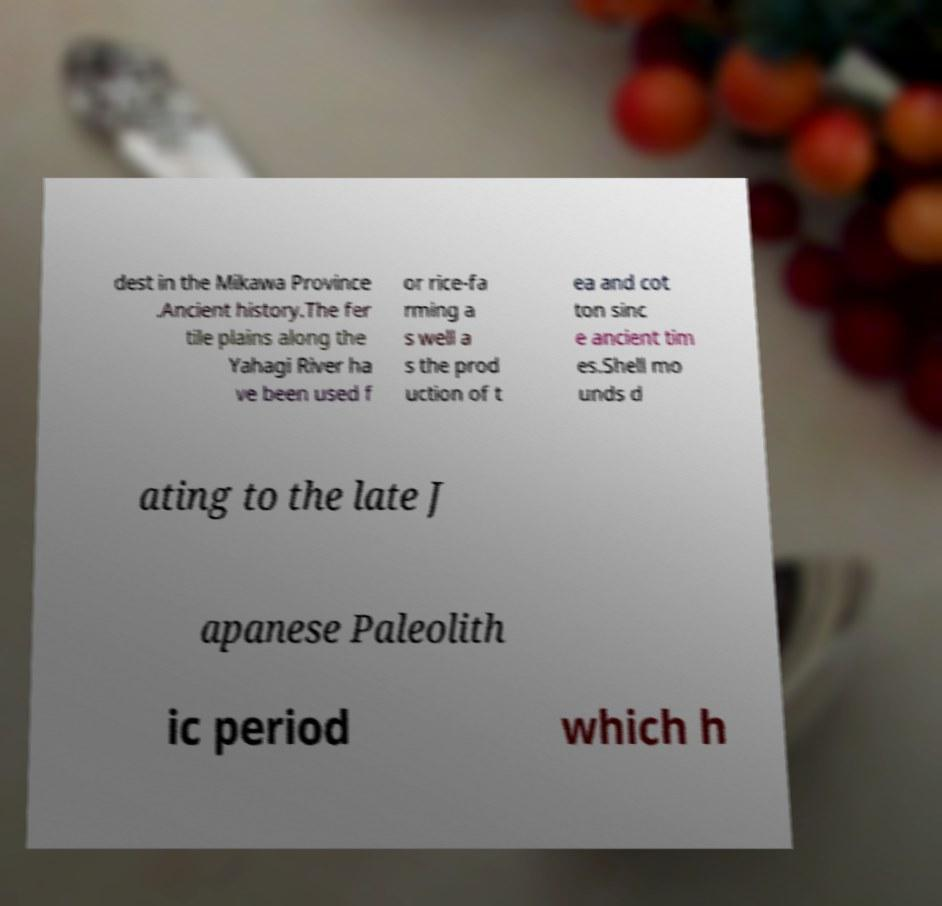For documentation purposes, I need the text within this image transcribed. Could you provide that? dest in the Mikawa Province .Ancient history.The fer tile plains along the Yahagi River ha ve been used f or rice-fa rming a s well a s the prod uction of t ea and cot ton sinc e ancient tim es.Shell mo unds d ating to the late J apanese Paleolith ic period which h 